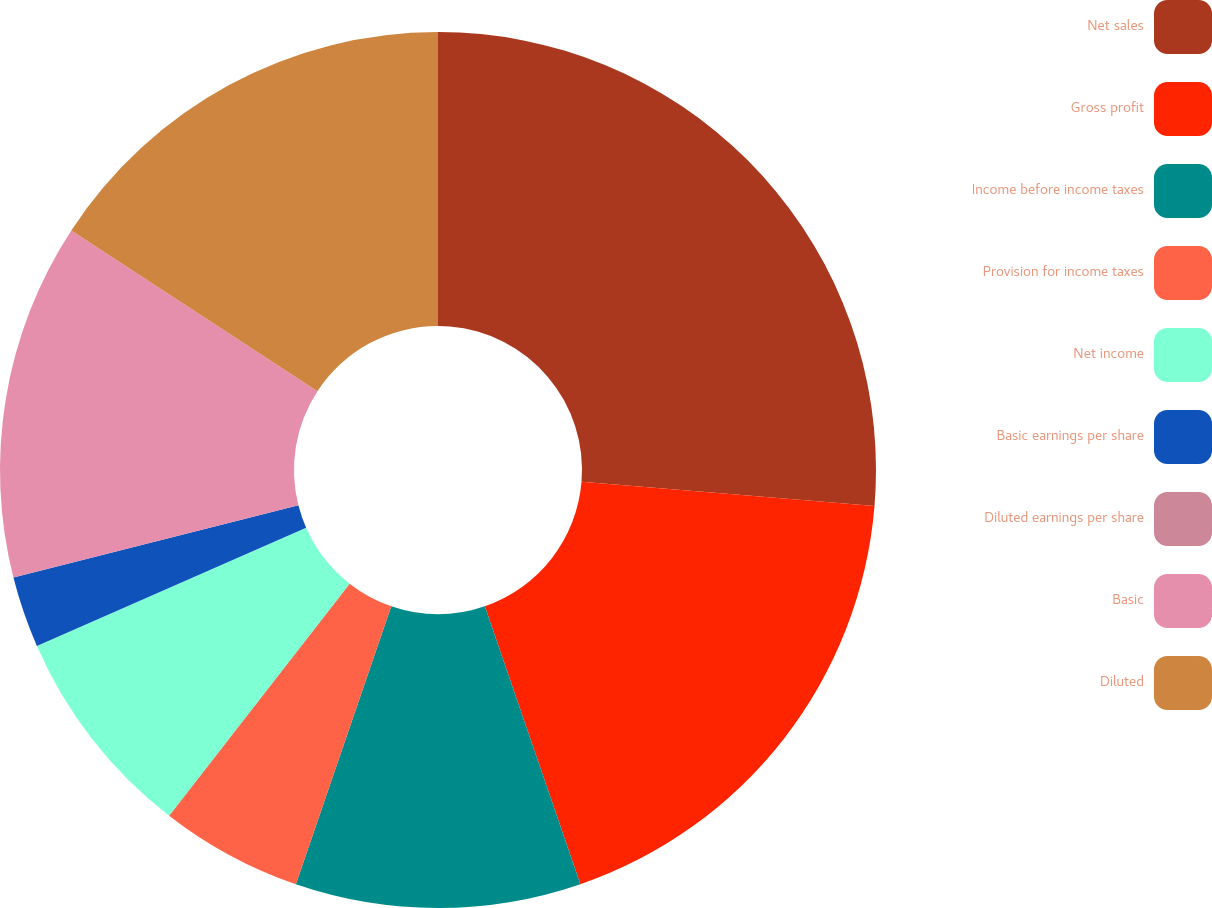Convert chart to OTSL. <chart><loc_0><loc_0><loc_500><loc_500><pie_chart><fcel>Net sales<fcel>Gross profit<fcel>Income before income taxes<fcel>Provision for income taxes<fcel>Net income<fcel>Basic earnings per share<fcel>Diluted earnings per share<fcel>Basic<fcel>Diluted<nl><fcel>26.31%<fcel>18.42%<fcel>10.53%<fcel>5.26%<fcel>7.9%<fcel>2.63%<fcel>0.0%<fcel>13.16%<fcel>15.79%<nl></chart> 